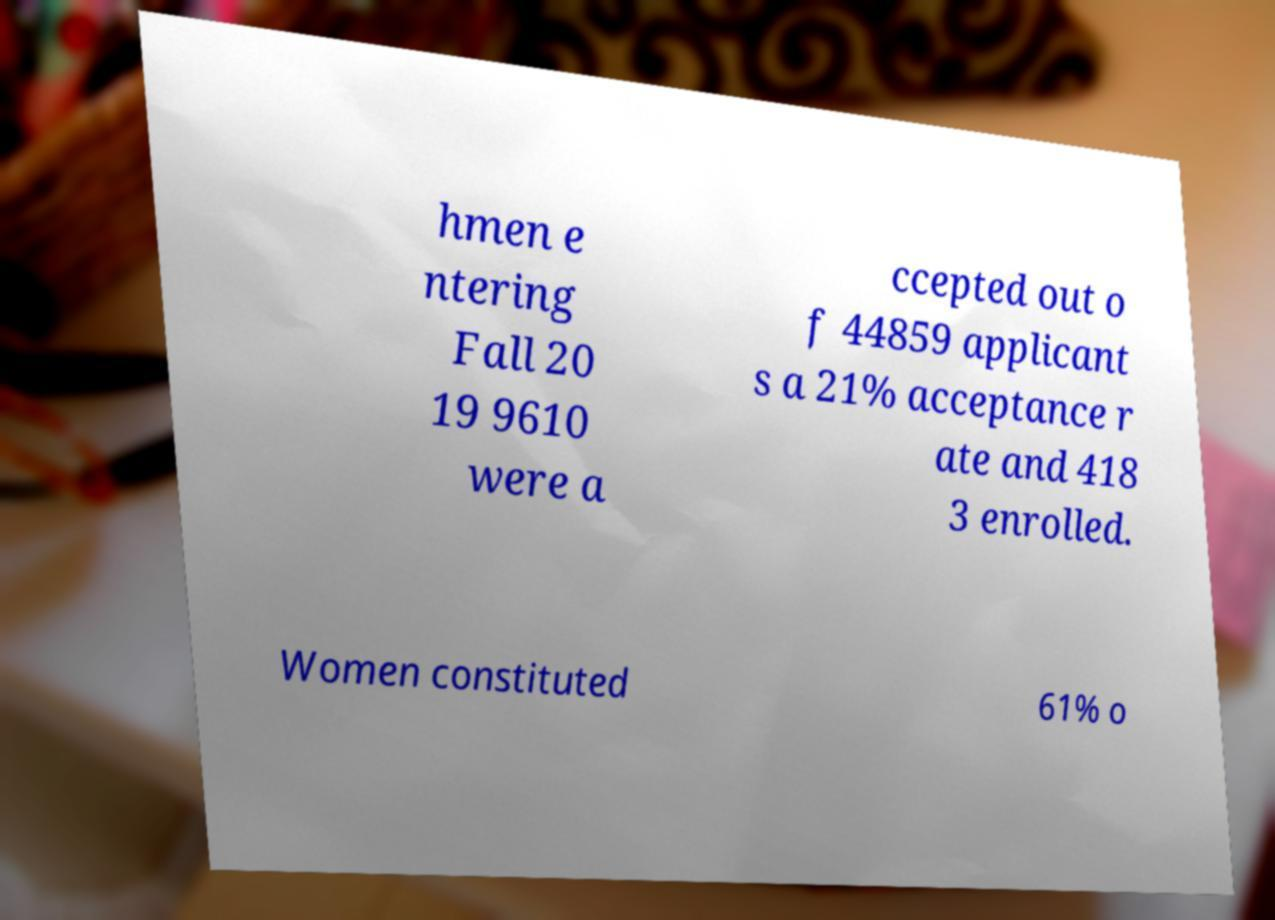Please identify and transcribe the text found in this image. hmen e ntering Fall 20 19 9610 were a ccepted out o f 44859 applicant s a 21% acceptance r ate and 418 3 enrolled. Women constituted 61% o 